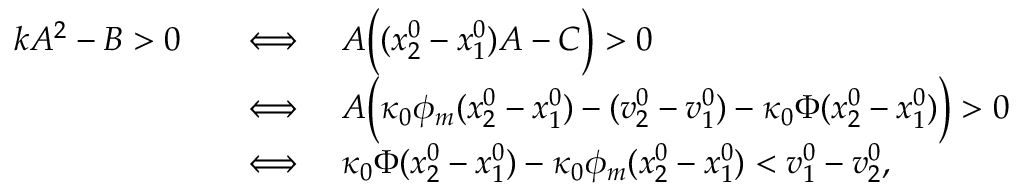<formula> <loc_0><loc_0><loc_500><loc_500>\begin{array} { r } { \begin{array} { r l } { k A ^ { 2 } - B > 0 \quad } & { \Longleftrightarrow \quad A \left ( ( x _ { 2 } ^ { 0 } - x _ { 1 } ^ { 0 } ) A - C \right ) > 0 } \\ & { \Longleftrightarrow \quad A \left ( \kappa _ { 0 } \phi _ { m } ( x _ { 2 } ^ { 0 } - x _ { 1 } ^ { 0 } ) - ( v _ { 2 } ^ { 0 } - v _ { 1 } ^ { 0 } ) - \kappa _ { 0 } \Phi ( x _ { 2 } ^ { 0 } - x _ { 1 } ^ { 0 } ) \right ) > 0 } \\ & { \Longleftrightarrow \quad \kappa _ { 0 } \Phi ( x _ { 2 } ^ { 0 } - x _ { 1 } ^ { 0 } ) - \kappa _ { 0 } \phi _ { m } ( x _ { 2 } ^ { 0 } - x _ { 1 } ^ { 0 } ) < v _ { 1 } ^ { 0 } - v _ { 2 } ^ { 0 } , } \end{array} } \end{array}</formula> 